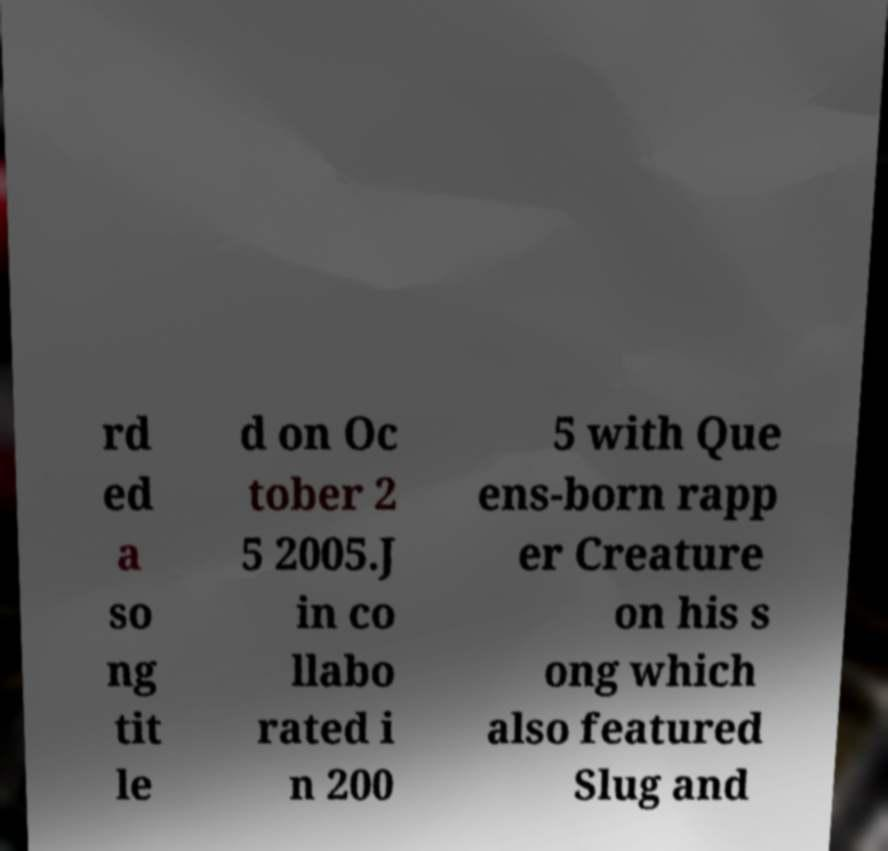For documentation purposes, I need the text within this image transcribed. Could you provide that? rd ed a so ng tit le d on Oc tober 2 5 2005.J in co llabo rated i n 200 5 with Que ens-born rapp er Creature on his s ong which also featured Slug and 